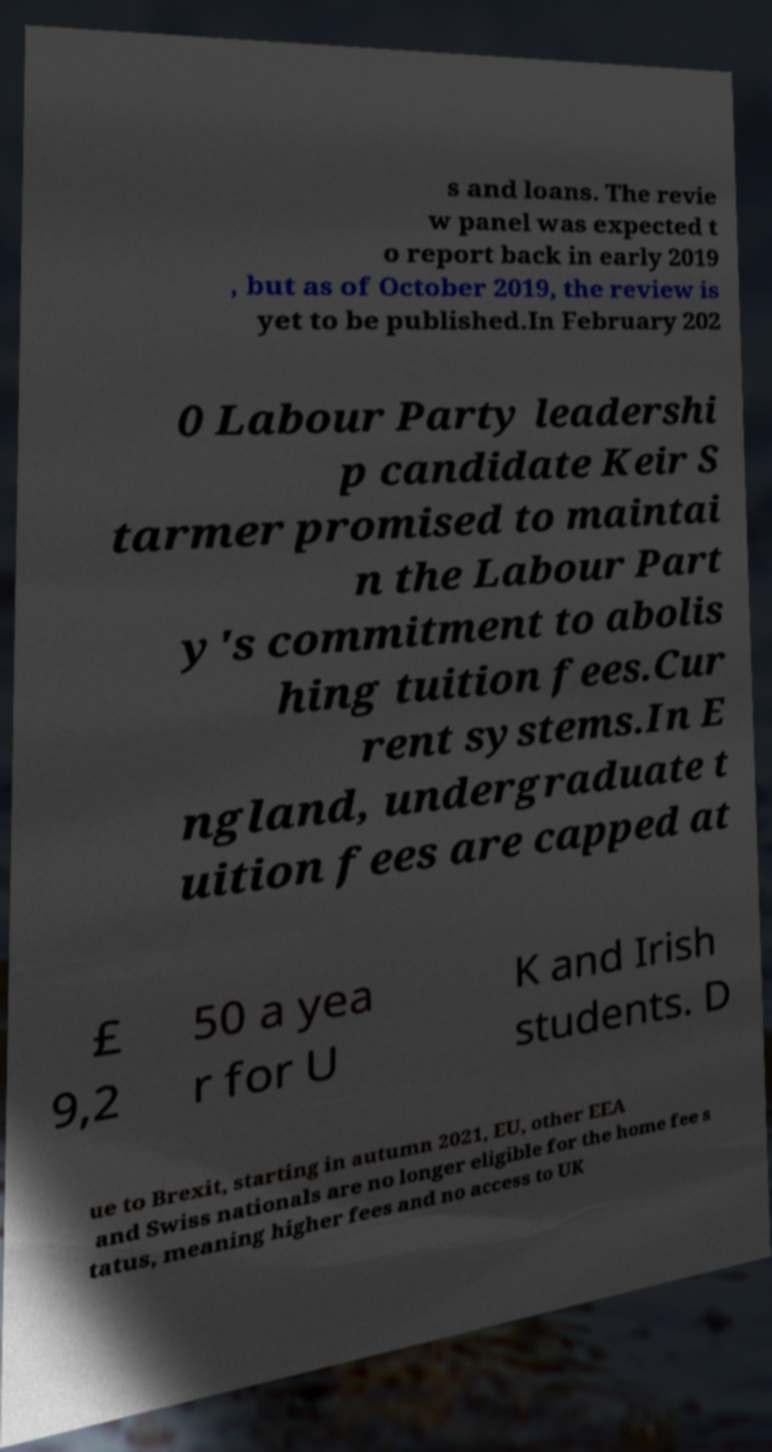Can you read and provide the text displayed in the image?This photo seems to have some interesting text. Can you extract and type it out for me? s and loans. The revie w panel was expected t o report back in early 2019 , but as of October 2019, the review is yet to be published.In February 202 0 Labour Party leadershi p candidate Keir S tarmer promised to maintai n the Labour Part y's commitment to abolis hing tuition fees.Cur rent systems.In E ngland, undergraduate t uition fees are capped at £ 9,2 50 a yea r for U K and Irish students. D ue to Brexit, starting in autumn 2021, EU, other EEA and Swiss nationals are no longer eligible for the home fee s tatus, meaning higher fees and no access to UK 